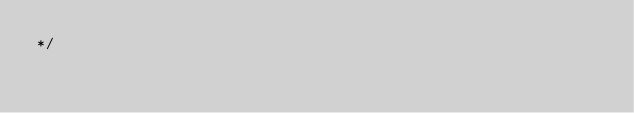<code> <loc_0><loc_0><loc_500><loc_500><_CSS_>*/</code> 